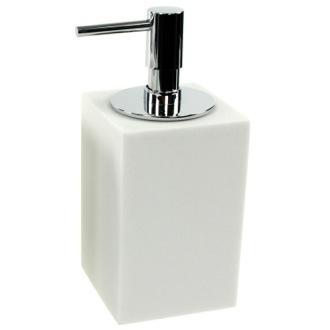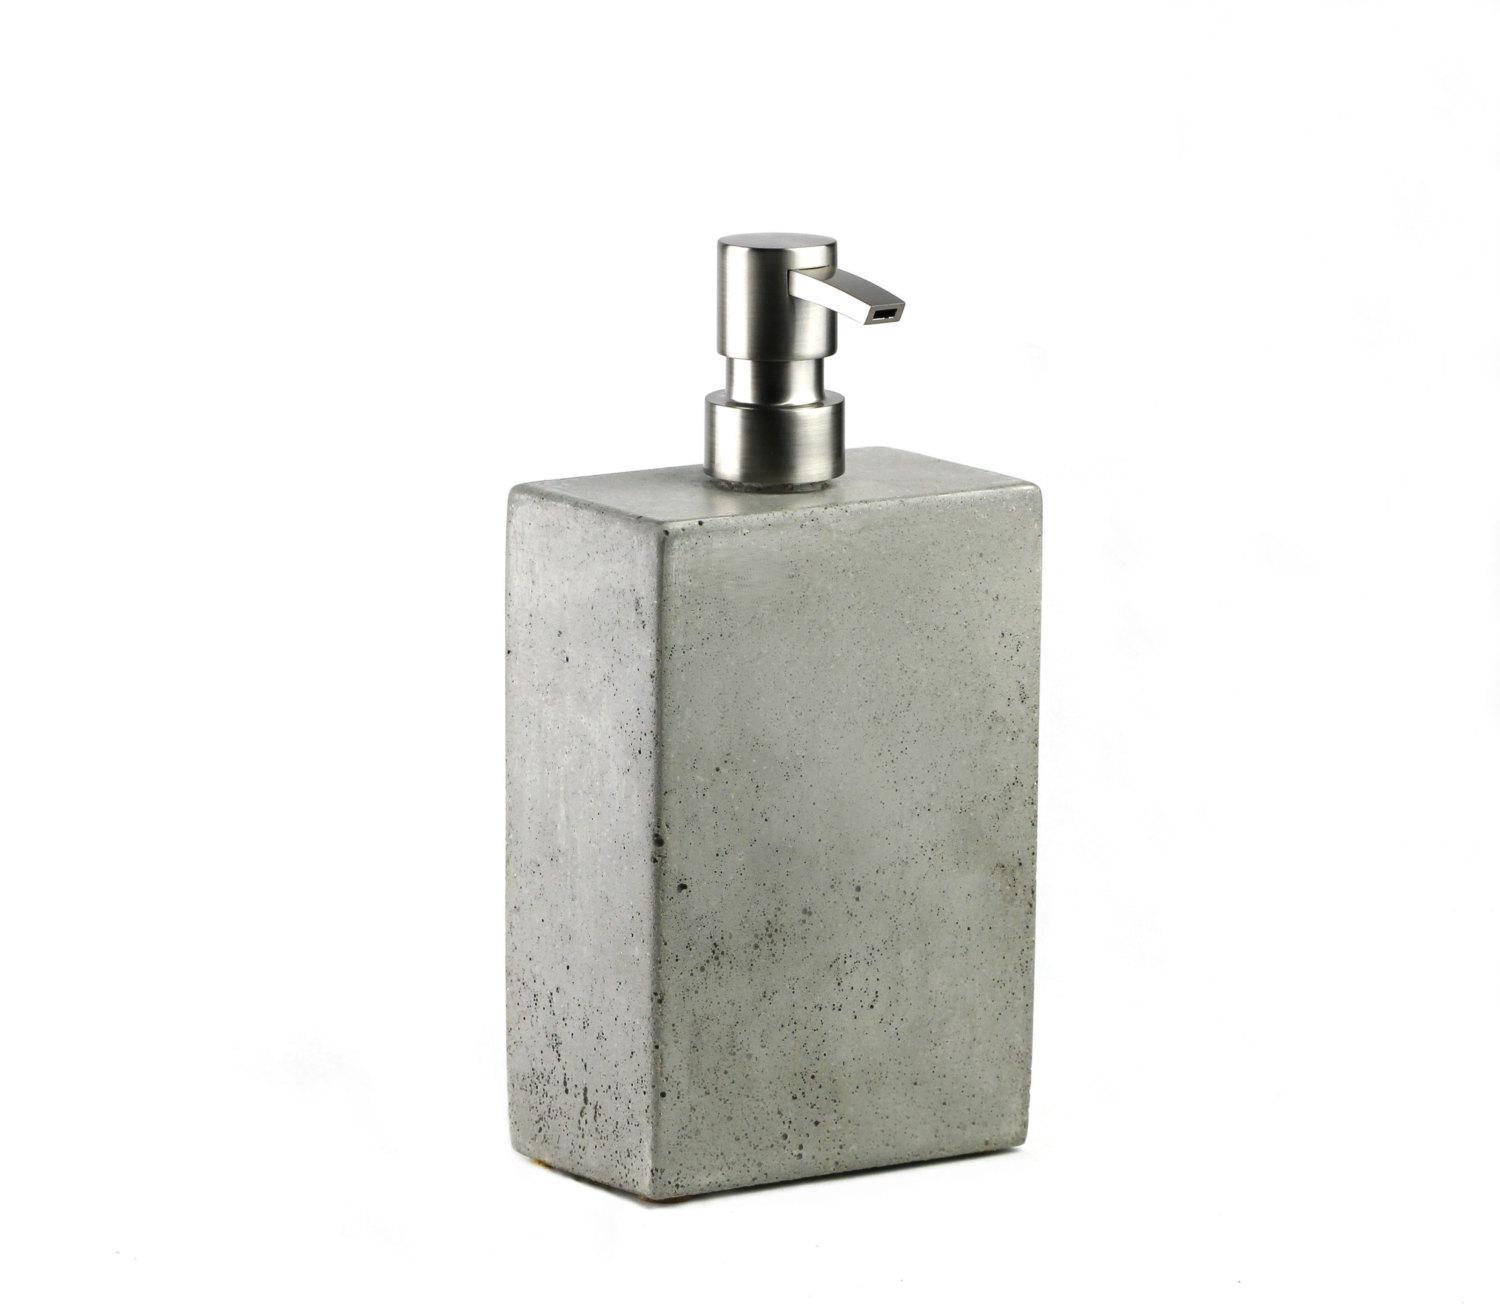The first image is the image on the left, the second image is the image on the right. For the images shown, is this caption "The dispenser on the right is taller than the dispenser on the left." true? Answer yes or no. No. 